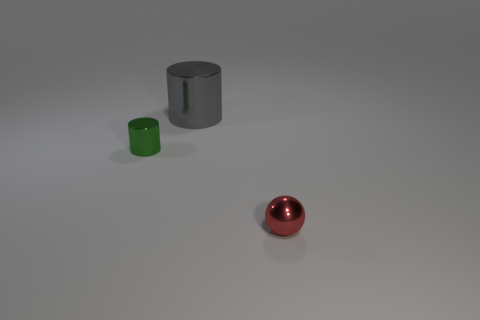Add 1 gray cylinders. How many objects exist? 4 Subtract all spheres. How many objects are left? 2 Subtract all big red rubber objects. Subtract all big metallic things. How many objects are left? 2 Add 1 big things. How many big things are left? 2 Add 3 big purple metal cubes. How many big purple metal cubes exist? 3 Subtract 0 blue cubes. How many objects are left? 3 